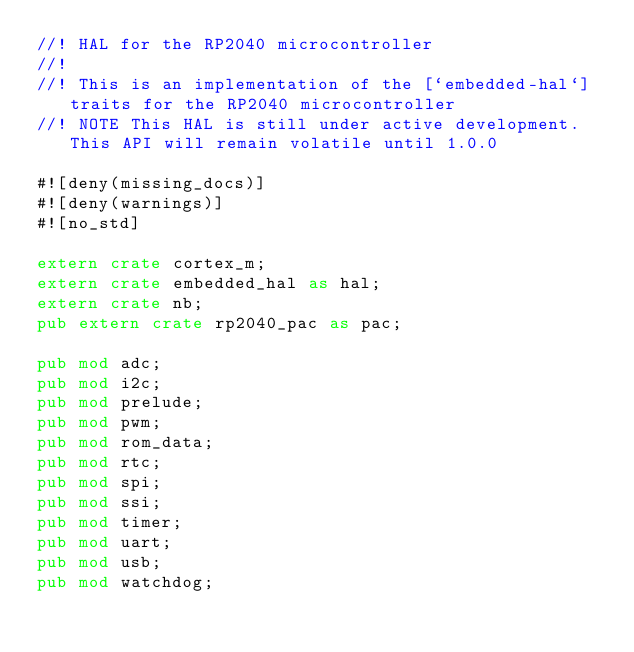Convert code to text. <code><loc_0><loc_0><loc_500><loc_500><_Rust_>//! HAL for the RP2040 microcontroller
//!
//! This is an implementation of the [`embedded-hal`] traits for the RP2040 microcontroller
//! NOTE This HAL is still under active development. This API will remain volatile until 1.0.0

#![deny(missing_docs)]
#![deny(warnings)]
#![no_std]

extern crate cortex_m;
extern crate embedded_hal as hal;
extern crate nb;
pub extern crate rp2040_pac as pac;

pub mod adc;
pub mod i2c;
pub mod prelude;
pub mod pwm;
pub mod rom_data;
pub mod rtc;
pub mod spi;
pub mod ssi;
pub mod timer;
pub mod uart;
pub mod usb;
pub mod watchdog;
</code> 